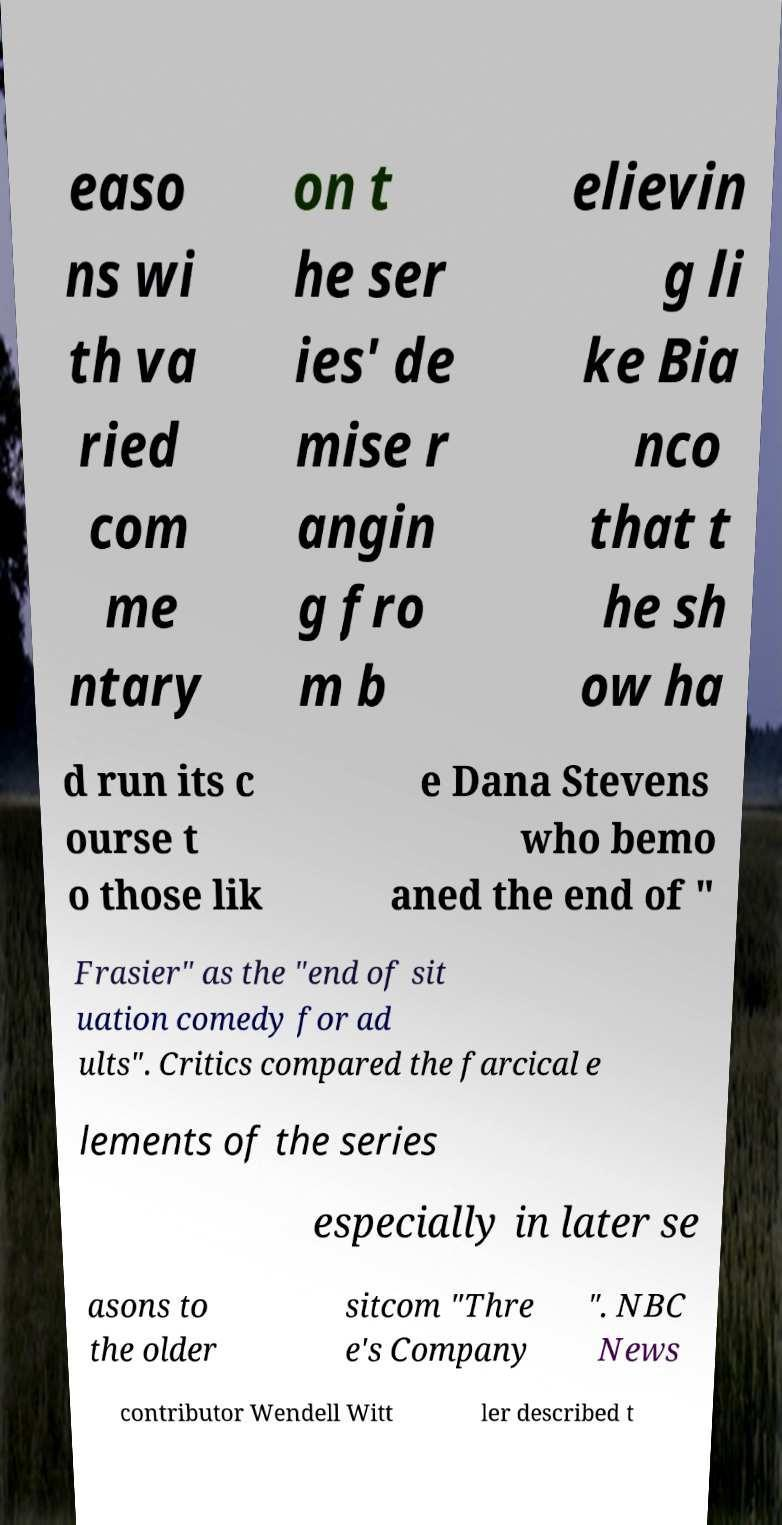I need the written content from this picture converted into text. Can you do that? easo ns wi th va ried com me ntary on t he ser ies' de mise r angin g fro m b elievin g li ke Bia nco that t he sh ow ha d run its c ourse t o those lik e Dana Stevens who bemo aned the end of " Frasier" as the "end of sit uation comedy for ad ults". Critics compared the farcical e lements of the series especially in later se asons to the older sitcom "Thre e's Company ". NBC News contributor Wendell Witt ler described t 